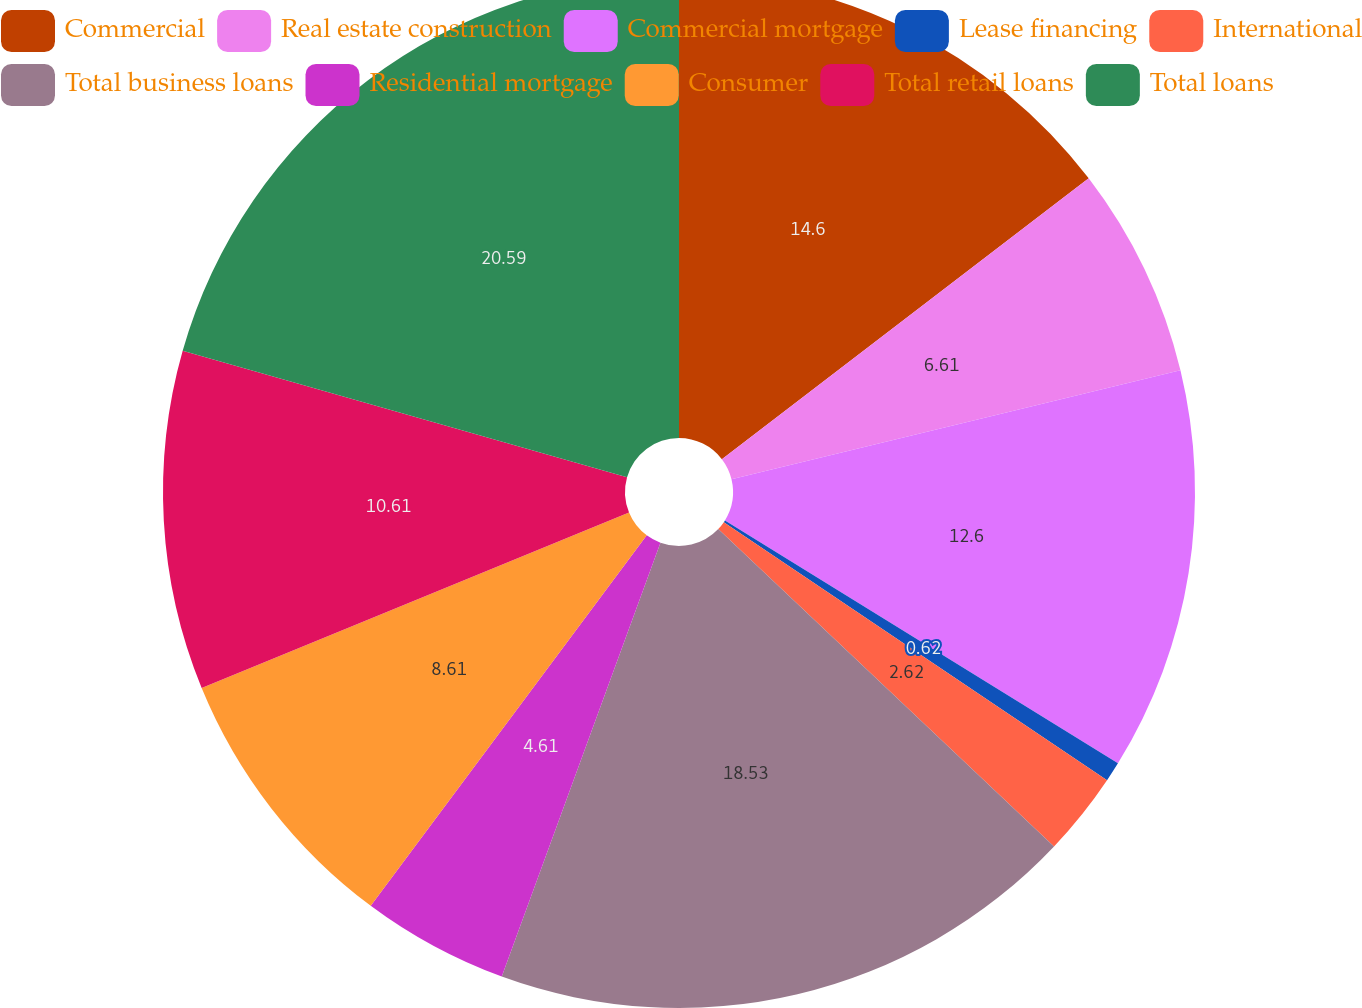Convert chart. <chart><loc_0><loc_0><loc_500><loc_500><pie_chart><fcel>Commercial<fcel>Real estate construction<fcel>Commercial mortgage<fcel>Lease financing<fcel>International<fcel>Total business loans<fcel>Residential mortgage<fcel>Consumer<fcel>Total retail loans<fcel>Total loans<nl><fcel>14.6%<fcel>6.61%<fcel>12.6%<fcel>0.62%<fcel>2.62%<fcel>18.53%<fcel>4.61%<fcel>8.61%<fcel>10.61%<fcel>20.59%<nl></chart> 